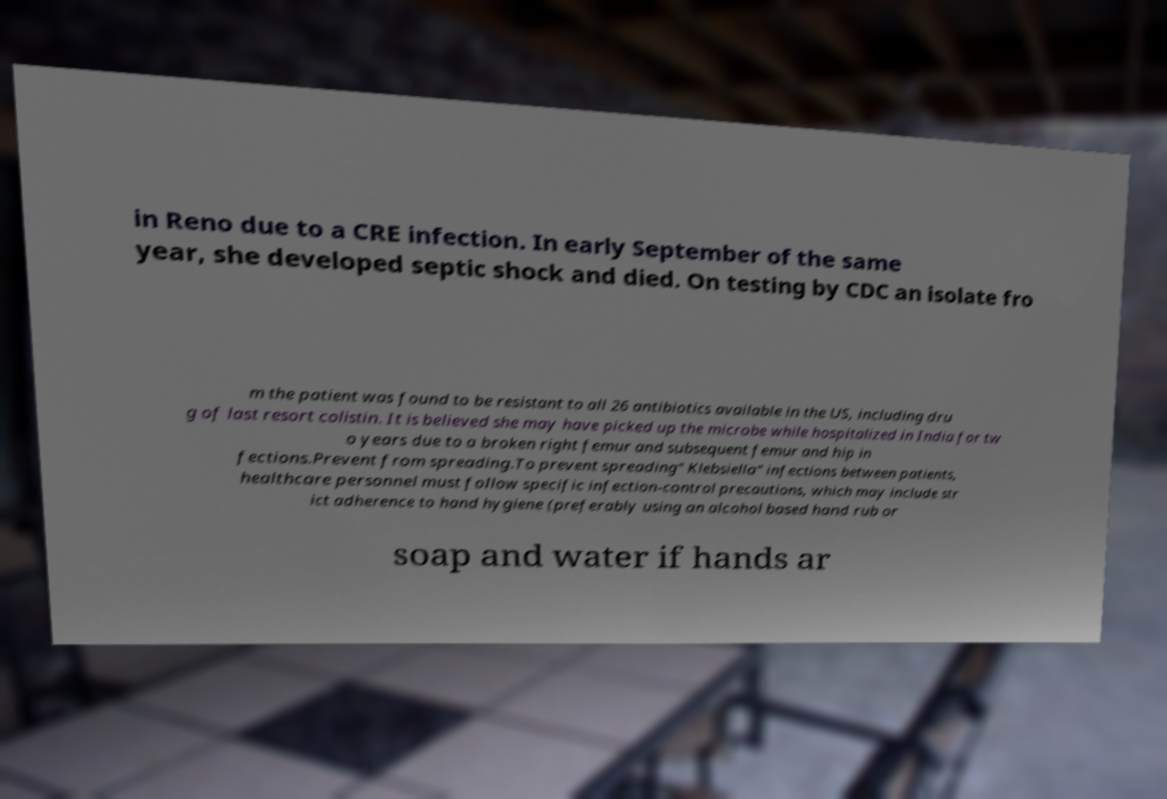Can you accurately transcribe the text from the provided image for me? in Reno due to a CRE infection. In early September of the same year, she developed septic shock and died. On testing by CDC an isolate fro m the patient was found to be resistant to all 26 antibiotics available in the US, including dru g of last resort colistin. It is believed she may have picked up the microbe while hospitalized in India for tw o years due to a broken right femur and subsequent femur and hip in fections.Prevent from spreading.To prevent spreading" Klebsiella" infections between patients, healthcare personnel must follow specific infection-control precautions, which may include str ict adherence to hand hygiene (preferably using an alcohol based hand rub or soap and water if hands ar 